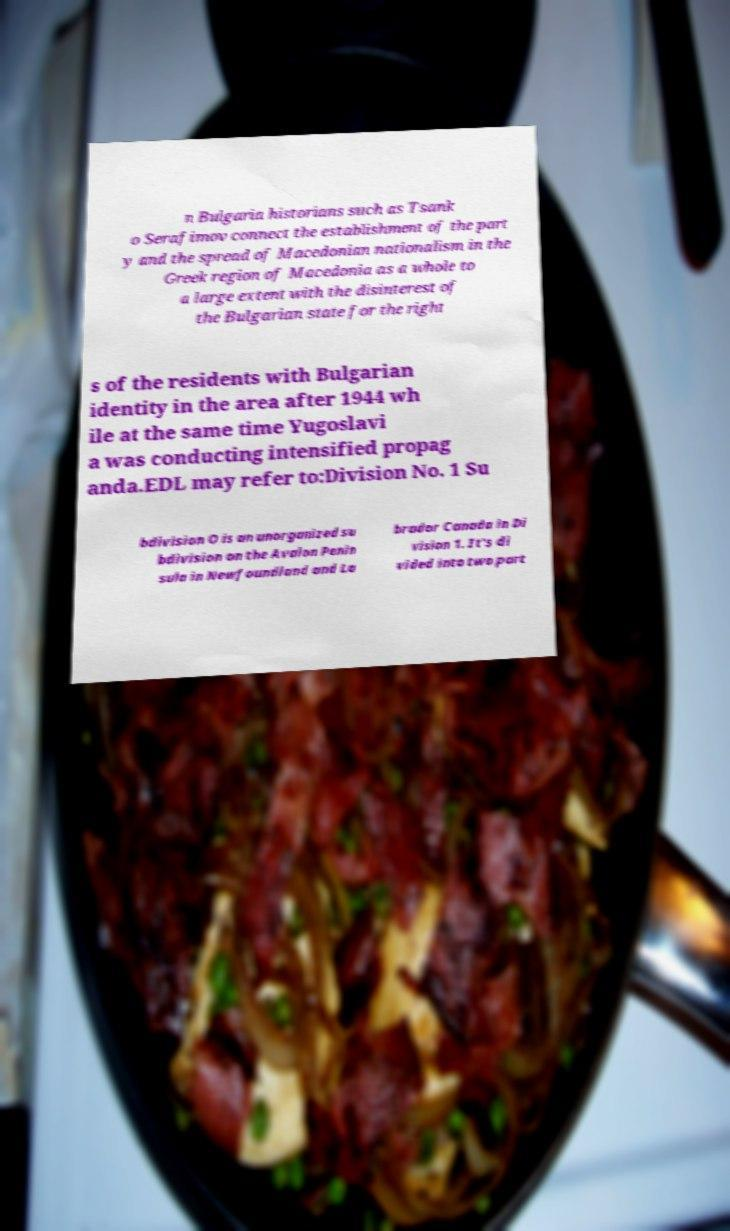Could you assist in decoding the text presented in this image and type it out clearly? n Bulgaria historians such as Tsank o Serafimov connect the establishment of the part y and the spread of Macedonian nationalism in the Greek region of Macedonia as a whole to a large extent with the disinterest of the Bulgarian state for the right s of the residents with Bulgarian identity in the area after 1944 wh ile at the same time Yugoslavi a was conducting intensified propag anda.EDL may refer to:Division No. 1 Su bdivision O is an unorganized su bdivision on the Avalon Penin sula in Newfoundland and La brador Canada in Di vision 1. It's di vided into two part 